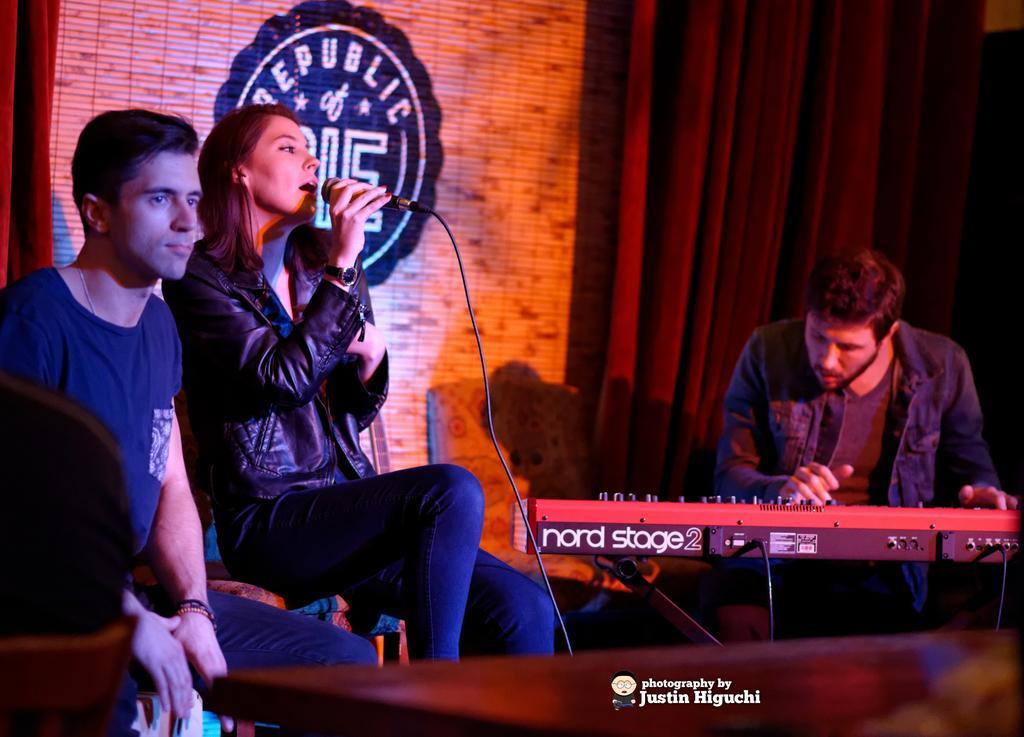In one or two sentences, can you explain what this image depicts? In this image I can see a woman wearing black colored jacket and jeans is sitting and holding a microphone in her hand. I can see a person wearing blue t shirt and blue jeans is sitting and in the background I can see another person sitting in front of a musical instrument, the red colored curtain and the brown colored wall. 